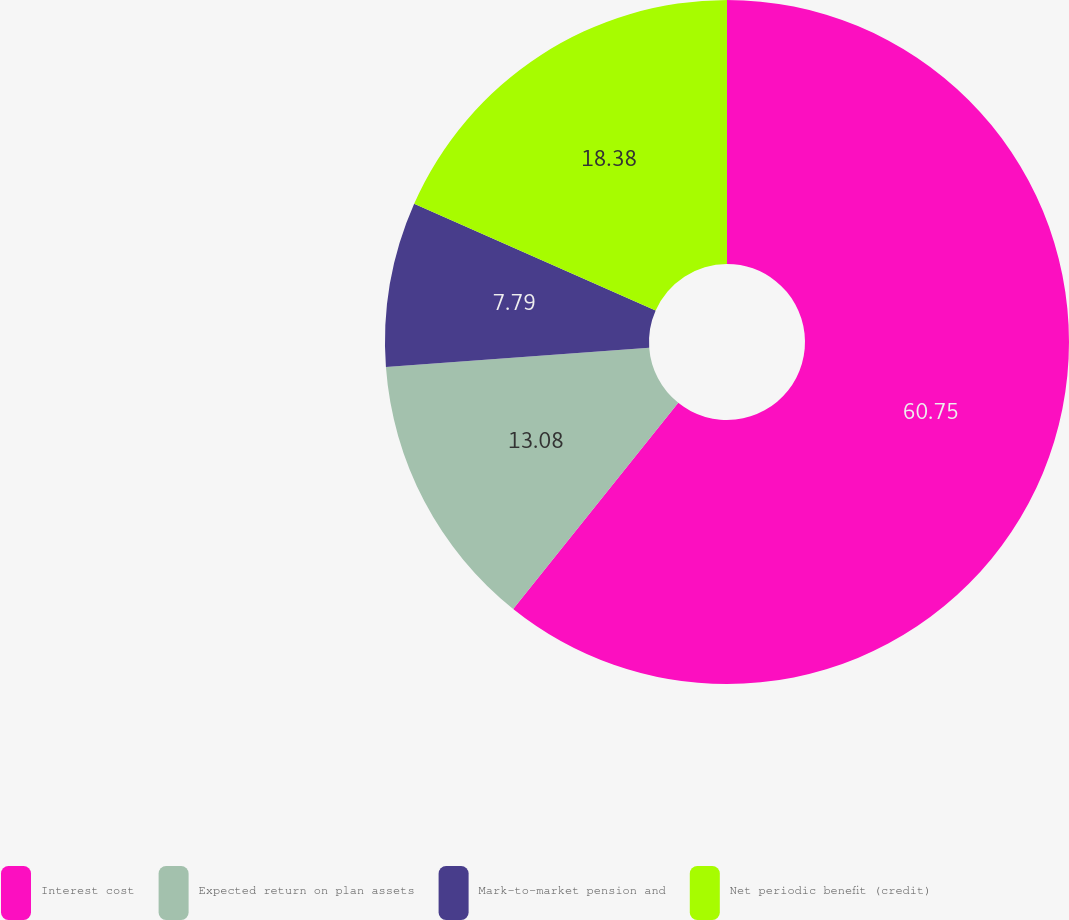Convert chart. <chart><loc_0><loc_0><loc_500><loc_500><pie_chart><fcel>Interest cost<fcel>Expected return on plan assets<fcel>Mark-to-market pension and<fcel>Net periodic benefit (credit)<nl><fcel>60.75%<fcel>13.08%<fcel>7.79%<fcel>18.38%<nl></chart> 